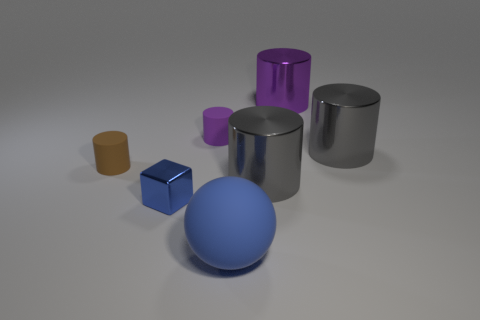What shape is the large thing that is behind the tiny brown object and in front of the large purple metallic object?
Offer a very short reply. Cylinder. There is a big object that is the same material as the small purple object; what shape is it?
Your answer should be compact. Sphere. There is a big gray object that is behind the tiny brown object; what is it made of?
Provide a succinct answer. Metal. There is a purple cylinder on the right side of the sphere; is its size the same as the rubber sphere to the left of the big purple thing?
Your answer should be very brief. Yes. The metallic cube is what color?
Your answer should be very brief. Blue. There is a big gray object that is in front of the small brown cylinder; is its shape the same as the brown object?
Your answer should be very brief. Yes. What is the tiny blue cube made of?
Offer a very short reply. Metal. There is a blue thing that is the same size as the brown cylinder; what shape is it?
Your answer should be compact. Cube. Are there any small things of the same color as the big ball?
Your answer should be compact. Yes. Do the sphere and the metallic object that is left of the large ball have the same color?
Ensure brevity in your answer.  Yes. 